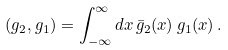<formula> <loc_0><loc_0><loc_500><loc_500>( g _ { 2 } , g _ { 1 } ) = \int _ { - \infty } ^ { \infty } d x \, \bar { g } _ { 2 } ( x ) \, g _ { 1 } ( x ) \, .</formula> 